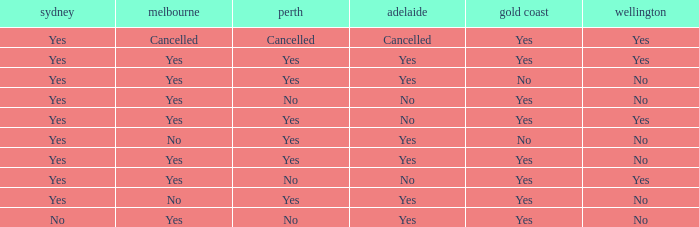What is The Melbourne with a No- Gold Coast Yes, No. 